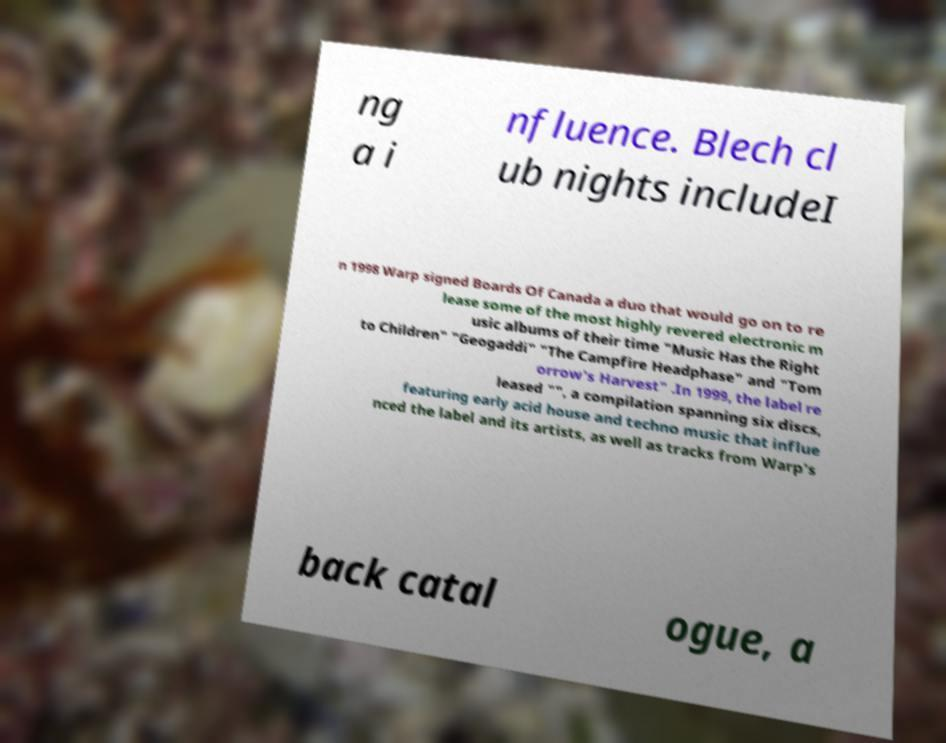Could you assist in decoding the text presented in this image and type it out clearly? ng a i nfluence. Blech cl ub nights includeI n 1998 Warp signed Boards Of Canada a duo that would go on to re lease some of the most highly revered electronic m usic albums of their time "Music Has the Right to Children" "Geogaddi" "The Campfire Headphase" and "Tom orrow's Harvest" .In 1999, the label re leased "", a compilation spanning six discs, featuring early acid house and techno music that influe nced the label and its artists, as well as tracks from Warp's back catal ogue, a 